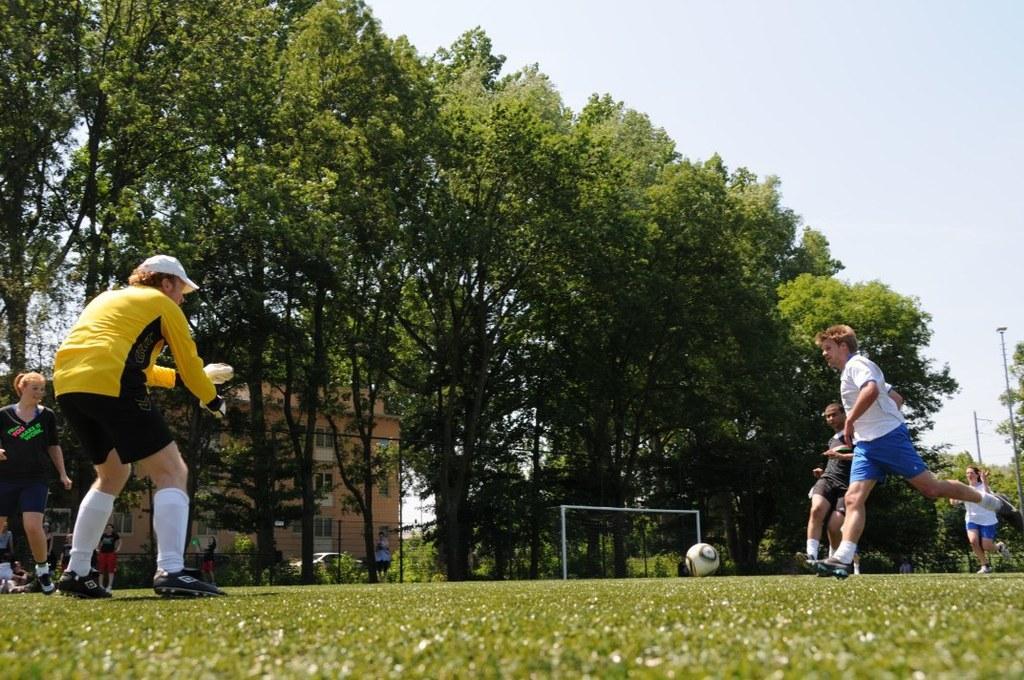How would you summarize this image in a sentence or two? An outside picture. Trees are line by line. Far there is a building with windows. This person is standing on a grass. This persons are running, as there is a leg movement. These is a ball. This woman is standing. Sky is in white color. Far there are poles. 